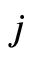Convert formula to latex. <formula><loc_0><loc_0><loc_500><loc_500>j</formula> 